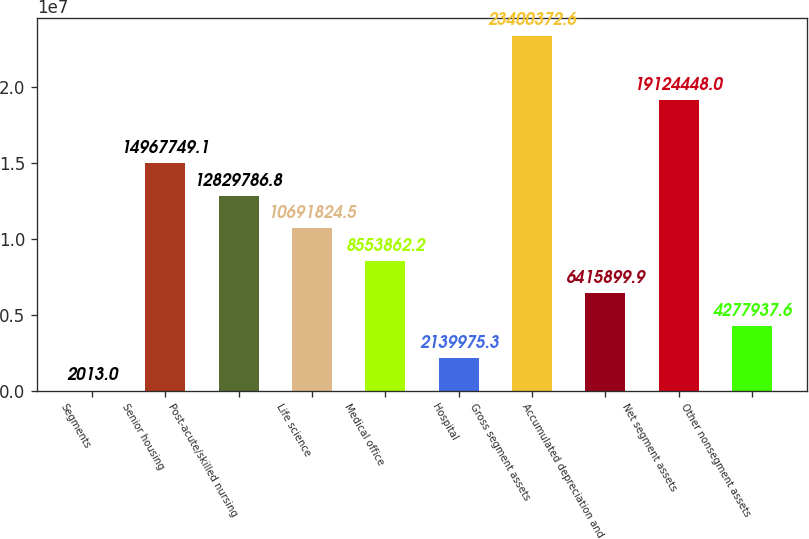Convert chart to OTSL. <chart><loc_0><loc_0><loc_500><loc_500><bar_chart><fcel>Segments<fcel>Senior housing<fcel>Post-acute/skilled nursing<fcel>Life science<fcel>Medical office<fcel>Hospital<fcel>Gross segment assets<fcel>Accumulated depreciation and<fcel>Net segment assets<fcel>Other nonsegment assets<nl><fcel>2013<fcel>1.49677e+07<fcel>1.28298e+07<fcel>1.06918e+07<fcel>8.55386e+06<fcel>2.13998e+06<fcel>2.34004e+07<fcel>6.4159e+06<fcel>1.91244e+07<fcel>4.27794e+06<nl></chart> 